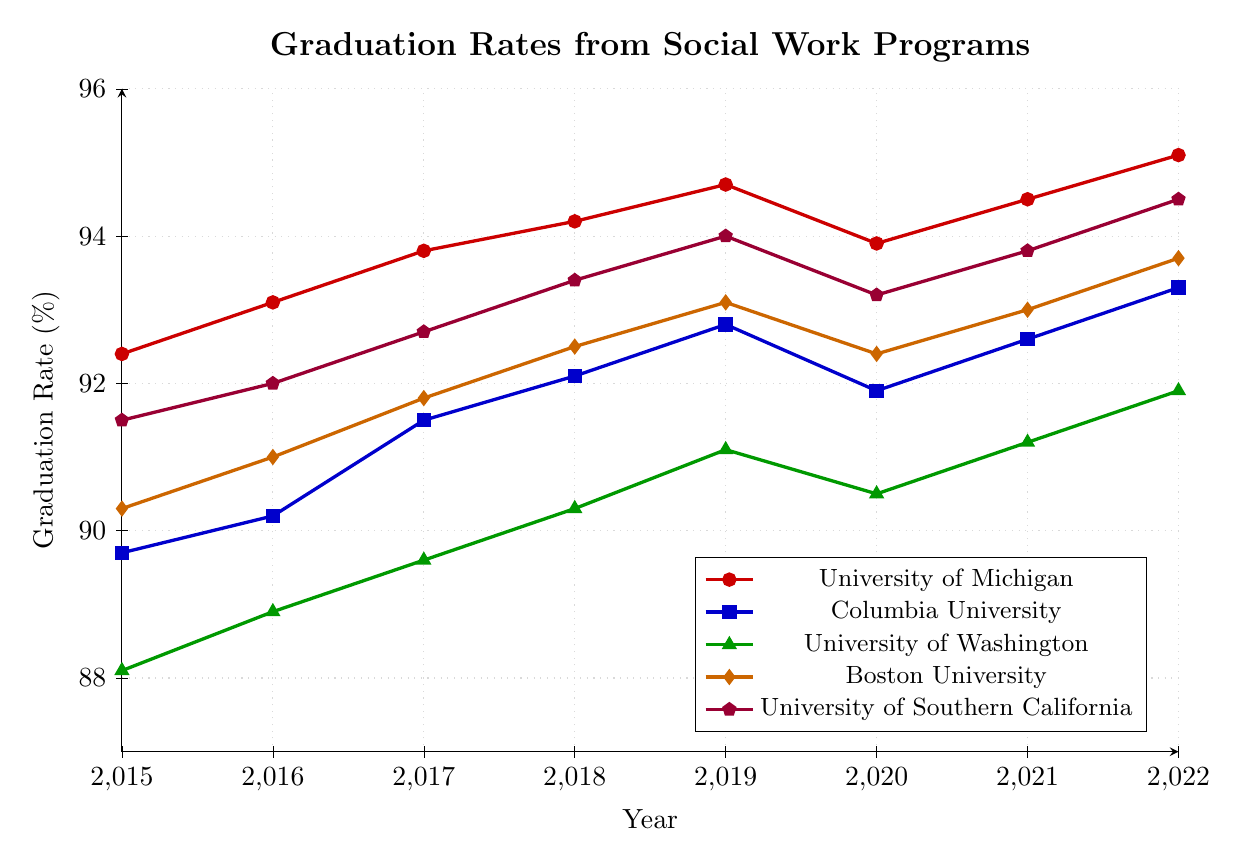What's the overall trend in graduation rates for the University of Michigan from 2015 to 2022? The graduation rate for the University of Michigan follows an increasing trend from 92.4% in 2015 to 95.1% in 2022 with minor fluctuations.
Answer: Increasing Which university had the highest graduation rate in 2020? By visual inspection of the plotted points in 2020, the University of Michigan had the highest graduation rate with 93.9%.
Answer: University of Michigan In which year did Boston University's graduation rate surpass Columbia University's graduation rate? Observing the intersecting points in the plot, Boston University's rate surpassed Columbia University's rate in 2015.
Answer: 2015 Which university exhibited the most consistent increase in graduation rates from 2015 to 2022? By examining the plot, the University of Southern California shows a steady and consistent increase in graduation rates from 91.5% in 2015 to 94.5% in 2022.
Answer: University of Southern California Comparing the universities, which had the lowest graduation rate in 2015? Looking at the points on the figure for 2015, the University of Washington had the lowest graduation rate at 88.1%.
Answer: University of Washington What is the average graduation rate for Columbia University from 2015 to 2022? Adding the graduation rates for each year from 2015 to 2022 and dividing by the number of years: (89.7 + 90.2 + 91.5 + 92.1 + 92.8 + 91.9 + 92.6 + 93.3) / 8 = 91.26.
Answer: 91.26% By how much did the graduation rate change for the University of Washington from 2019 to 2020? The graduation rate for the University of Washington in 2019 was 91.1%, and in 2020 it was 90.5%. The change is 91.1 - 90.5 = 0.6%.
Answer: 0.6% In 2022, which two universities had the closest graduation rates? Observing the plotted points for 2022, Columbia University had a graduation rate of 93.3% and Boston University had 93.7%, making their rates the closest.
Answer: Columbia University and Boston University How did the graduation rate of the University of Southern California change from 2016 to 2017? The graduation rate for the University of Southern California increased from 92.0% in 2016 to 92.7% in 2017. Therefore, the change is an increase of 0.7%.
Answer: Increased by 0.7% What is the difference in graduation rates between the University of Michigan and Columbia University in 2021? The graduation rate for the University of Michigan in 2021 was 94.5%, and for Columbia University, it was 92.6%. The difference is 94.5 - 92.6 = 1.9%.
Answer: 1.9% 